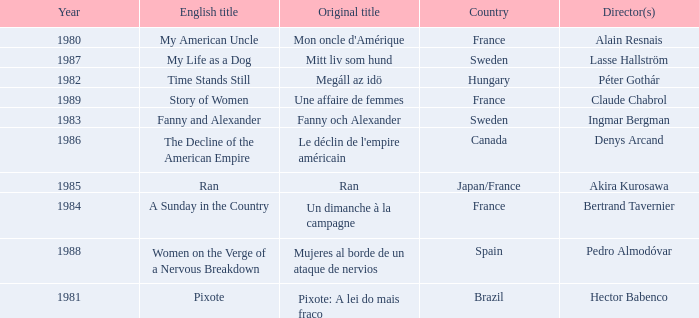What's the English Title of Fanny Och Alexander? Fanny and Alexander. Write the full table. {'header': ['Year', 'English title', 'Original title', 'Country', 'Director(s)'], 'rows': [['1980', 'My American Uncle', "Mon oncle d'Amérique", 'France', 'Alain Resnais'], ['1987', 'My Life as a Dog', 'Mitt liv som hund', 'Sweden', 'Lasse Hallström'], ['1982', 'Time Stands Still', 'Megáll az idö', 'Hungary', 'Péter Gothár'], ['1989', 'Story of Women', 'Une affaire de femmes', 'France', 'Claude Chabrol'], ['1983', 'Fanny and Alexander', 'Fanny och Alexander', 'Sweden', 'Ingmar Bergman'], ['1986', 'The Decline of the American Empire', "Le déclin de l'empire américain", 'Canada', 'Denys Arcand'], ['1985', 'Ran', 'Ran', 'Japan/France', 'Akira Kurosawa'], ['1984', 'A Sunday in the Country', 'Un dimanche à la campagne', 'France', 'Bertrand Tavernier'], ['1988', 'Women on the Verge of a Nervous Breakdown', 'Mujeres al borde de un ataque de nervios', 'Spain', 'Pedro Almodóvar'], ['1981', 'Pixote', 'Pixote: A lei do mais fraco', 'Brazil', 'Hector Babenco']]} 